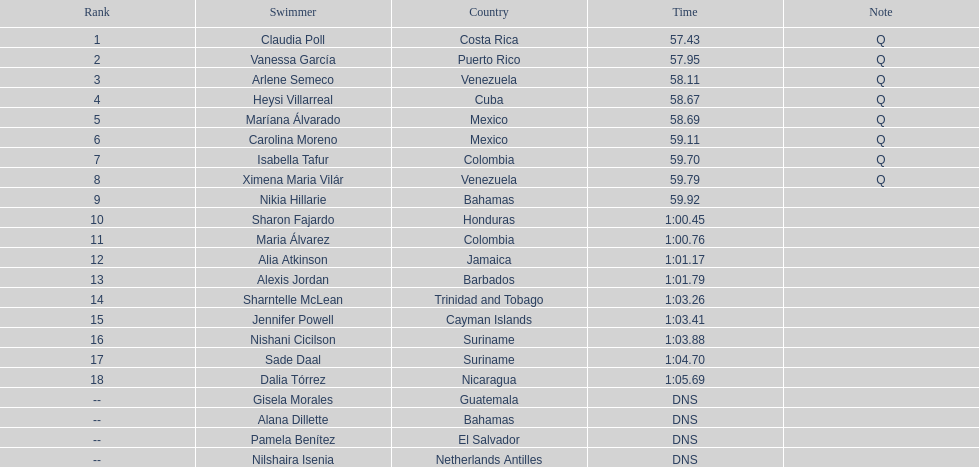Which swimmer had the longest time? Dalia Tórrez. Could you parse the entire table as a dict? {'header': ['Rank', 'Swimmer', 'Country', 'Time', 'Note'], 'rows': [['1', 'Claudia Poll', 'Costa Rica', '57.43', 'Q'], ['2', 'Vanessa García', 'Puerto Rico', '57.95', 'Q'], ['3', 'Arlene Semeco', 'Venezuela', '58.11', 'Q'], ['4', 'Heysi Villarreal', 'Cuba', '58.67', 'Q'], ['5', 'Maríana Álvarado', 'Mexico', '58.69', 'Q'], ['6', 'Carolina Moreno', 'Mexico', '59.11', 'Q'], ['7', 'Isabella Tafur', 'Colombia', '59.70', 'Q'], ['8', 'Ximena Maria Vilár', 'Venezuela', '59.79', 'Q'], ['9', 'Nikia Hillarie', 'Bahamas', '59.92', ''], ['10', 'Sharon Fajardo', 'Honduras', '1:00.45', ''], ['11', 'Maria Álvarez', 'Colombia', '1:00.76', ''], ['12', 'Alia Atkinson', 'Jamaica', '1:01.17', ''], ['13', 'Alexis Jordan', 'Barbados', '1:01.79', ''], ['14', 'Sharntelle McLean', 'Trinidad and Tobago', '1:03.26', ''], ['15', 'Jennifer Powell', 'Cayman Islands', '1:03.41', ''], ['16', 'Nishani Cicilson', 'Suriname', '1:03.88', ''], ['17', 'Sade Daal', 'Suriname', '1:04.70', ''], ['18', 'Dalia Tórrez', 'Nicaragua', '1:05.69', ''], ['--', 'Gisela Morales', 'Guatemala', 'DNS', ''], ['--', 'Alana Dillette', 'Bahamas', 'DNS', ''], ['--', 'Pamela Benítez', 'El Salvador', 'DNS', ''], ['--', 'Nilshaira Isenia', 'Netherlands Antilles', 'DNS', '']]} 